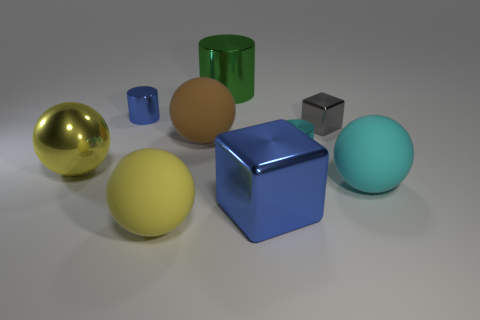Is there a yellow sphere that has the same size as the yellow metal object?
Ensure brevity in your answer.  Yes. Does the rubber thing on the right side of the small gray metallic thing have the same color as the ball behind the big shiny ball?
Your response must be concise. No. What number of metallic objects are large yellow cylinders or brown things?
Make the answer very short. 0. How many cylinders are right of the big yellow object that is in front of the cube in front of the tiny gray shiny cube?
Your answer should be very brief. 2. What size is the blue cylinder that is made of the same material as the large green cylinder?
Give a very brief answer. Small. What number of large objects are the same color as the large metal cube?
Provide a succinct answer. 0. There is a ball that is in front of the cyan sphere; does it have the same size as the gray metallic thing?
Ensure brevity in your answer.  No. There is a large metal thing that is in front of the big cylinder and behind the blue shiny cube; what is its color?
Your answer should be very brief. Yellow. How many objects are blocks or big objects left of the big shiny cube?
Your response must be concise. 6. There is a blue thing in front of the big matte sphere that is right of the big metallic object that is behind the gray metallic thing; what is it made of?
Provide a succinct answer. Metal. 